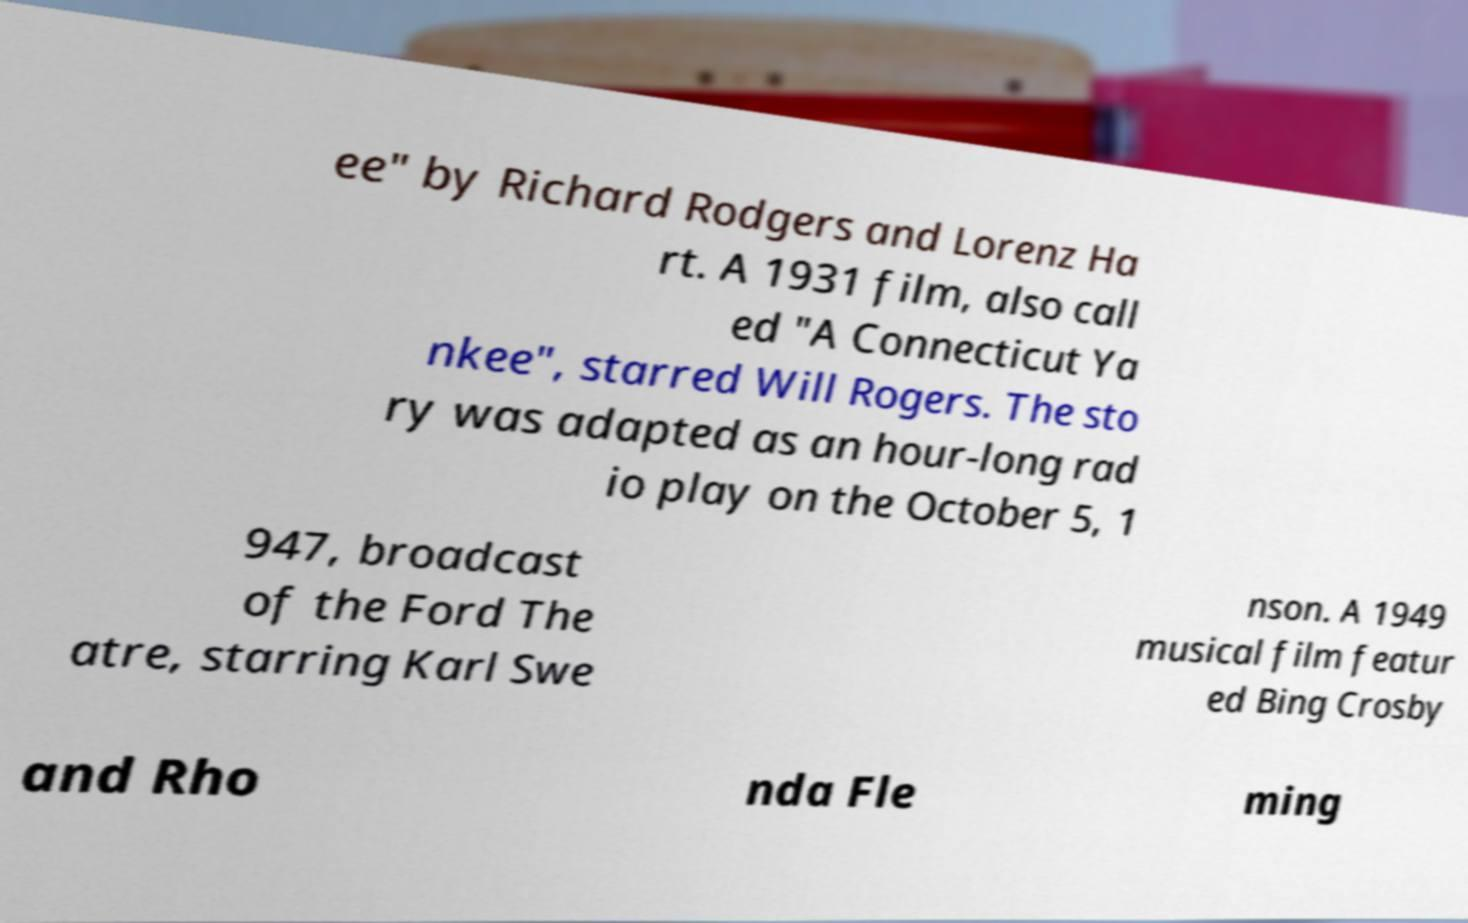Can you accurately transcribe the text from the provided image for me? ee" by Richard Rodgers and Lorenz Ha rt. A 1931 film, also call ed "A Connecticut Ya nkee", starred Will Rogers. The sto ry was adapted as an hour-long rad io play on the October 5, 1 947, broadcast of the Ford The atre, starring Karl Swe nson. A 1949 musical film featur ed Bing Crosby and Rho nda Fle ming 